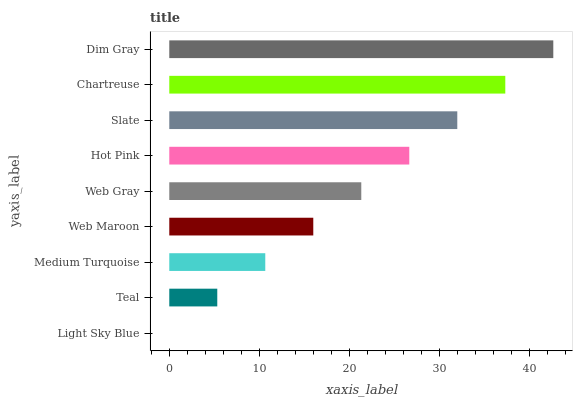Is Light Sky Blue the minimum?
Answer yes or no. Yes. Is Dim Gray the maximum?
Answer yes or no. Yes. Is Teal the minimum?
Answer yes or no. No. Is Teal the maximum?
Answer yes or no. No. Is Teal greater than Light Sky Blue?
Answer yes or no. Yes. Is Light Sky Blue less than Teal?
Answer yes or no. Yes. Is Light Sky Blue greater than Teal?
Answer yes or no. No. Is Teal less than Light Sky Blue?
Answer yes or no. No. Is Web Gray the high median?
Answer yes or no. Yes. Is Web Gray the low median?
Answer yes or no. Yes. Is Web Maroon the high median?
Answer yes or no. No. Is Dim Gray the low median?
Answer yes or no. No. 